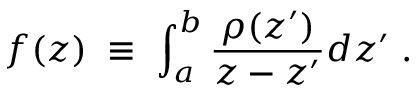<formula> <loc_0><loc_0><loc_500><loc_500>f ( z ) \, \equiv \, \int _ { a } ^ { b } { \frac { \rho ( z ^ { \prime } ) } { z - z ^ { \prime } } } d z ^ { \prime } \, .</formula> 